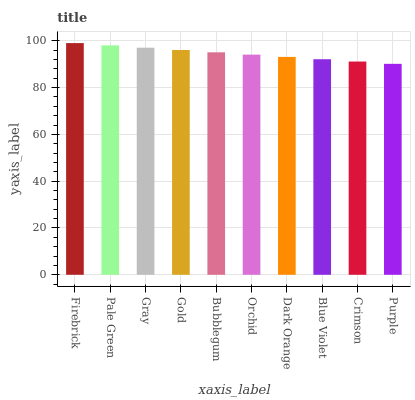Is Pale Green the minimum?
Answer yes or no. No. Is Pale Green the maximum?
Answer yes or no. No. Is Firebrick greater than Pale Green?
Answer yes or no. Yes. Is Pale Green less than Firebrick?
Answer yes or no. Yes. Is Pale Green greater than Firebrick?
Answer yes or no. No. Is Firebrick less than Pale Green?
Answer yes or no. No. Is Bubblegum the high median?
Answer yes or no. Yes. Is Orchid the low median?
Answer yes or no. Yes. Is Purple the high median?
Answer yes or no. No. Is Pale Green the low median?
Answer yes or no. No. 